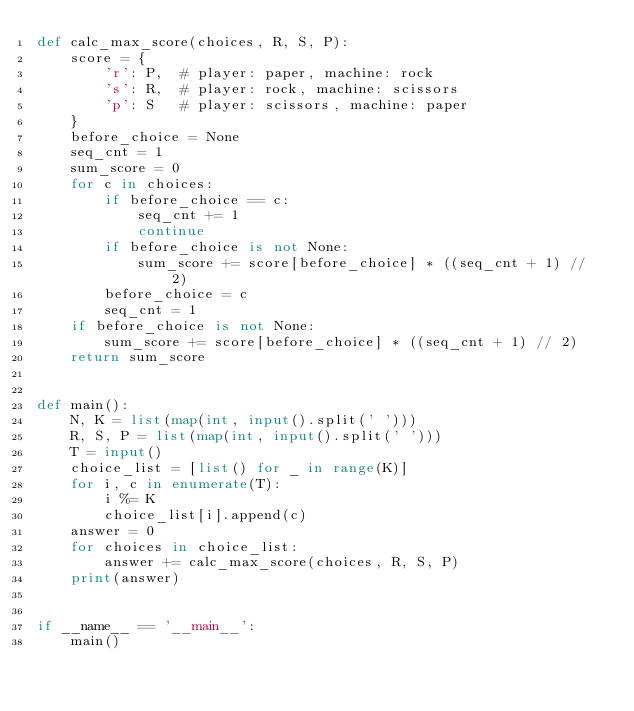Convert code to text. <code><loc_0><loc_0><loc_500><loc_500><_Python_>def calc_max_score(choices, R, S, P):
    score = {
        'r': P,  # player: paper, machine: rock
        's': R,  # player: rock, machine: scissors
        'p': S   # player: scissors, machine: paper
    }
    before_choice = None
    seq_cnt = 1
    sum_score = 0
    for c in choices:
        if before_choice == c:
            seq_cnt += 1
            continue
        if before_choice is not None:
            sum_score += score[before_choice] * ((seq_cnt + 1) // 2)
        before_choice = c
        seq_cnt = 1
    if before_choice is not None:
        sum_score += score[before_choice] * ((seq_cnt + 1) // 2)
    return sum_score


def main():
    N, K = list(map(int, input().split(' ')))
    R, S, P = list(map(int, input().split(' ')))
    T = input()
    choice_list = [list() for _ in range(K)]
    for i, c in enumerate(T):
        i %= K
        choice_list[i].append(c)
    answer = 0
    for choices in choice_list:
        answer += calc_max_score(choices, R, S, P)
    print(answer)


if __name__ == '__main__':
    main()
</code> 